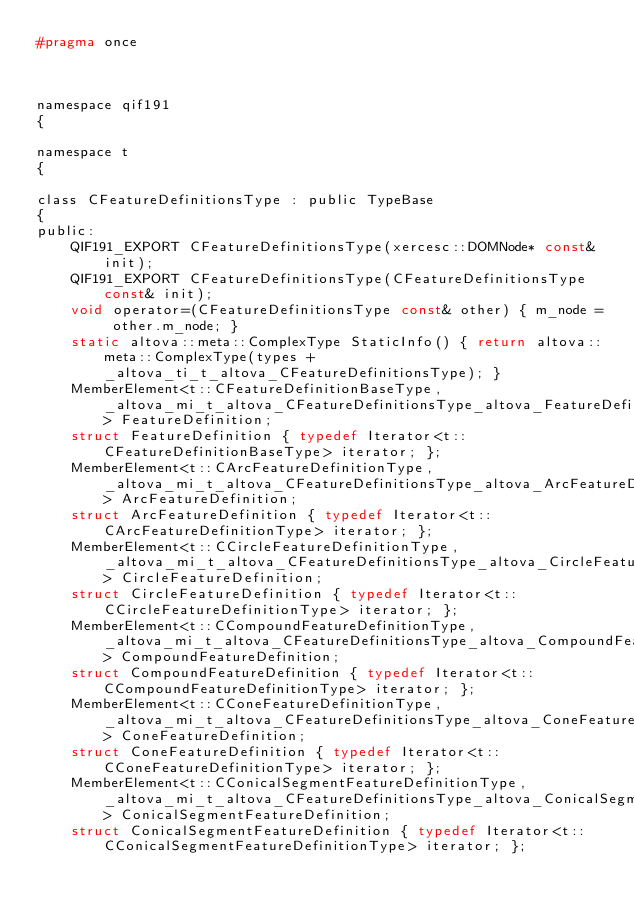<code> <loc_0><loc_0><loc_500><loc_500><_C_>#pragma once



namespace qif191
{

namespace t
{	

class CFeatureDefinitionsType : public TypeBase
{
public:
	QIF191_EXPORT CFeatureDefinitionsType(xercesc::DOMNode* const& init);
	QIF191_EXPORT CFeatureDefinitionsType(CFeatureDefinitionsType const& init);
	void operator=(CFeatureDefinitionsType const& other) { m_node = other.m_node; }
	static altova::meta::ComplexType StaticInfo() { return altova::meta::ComplexType(types + _altova_ti_t_altova_CFeatureDefinitionsType); }
	MemberElement<t::CFeatureDefinitionBaseType, _altova_mi_t_altova_CFeatureDefinitionsType_altova_FeatureDefinition> FeatureDefinition;
	struct FeatureDefinition { typedef Iterator<t::CFeatureDefinitionBaseType> iterator; };
	MemberElement<t::CArcFeatureDefinitionType, _altova_mi_t_altova_CFeatureDefinitionsType_altova_ArcFeatureDefinition> ArcFeatureDefinition;
	struct ArcFeatureDefinition { typedef Iterator<t::CArcFeatureDefinitionType> iterator; };
	MemberElement<t::CCircleFeatureDefinitionType, _altova_mi_t_altova_CFeatureDefinitionsType_altova_CircleFeatureDefinition> CircleFeatureDefinition;
	struct CircleFeatureDefinition { typedef Iterator<t::CCircleFeatureDefinitionType> iterator; };
	MemberElement<t::CCompoundFeatureDefinitionType, _altova_mi_t_altova_CFeatureDefinitionsType_altova_CompoundFeatureDefinition> CompoundFeatureDefinition;
	struct CompoundFeatureDefinition { typedef Iterator<t::CCompoundFeatureDefinitionType> iterator; };
	MemberElement<t::CConeFeatureDefinitionType, _altova_mi_t_altova_CFeatureDefinitionsType_altova_ConeFeatureDefinition> ConeFeatureDefinition;
	struct ConeFeatureDefinition { typedef Iterator<t::CConeFeatureDefinitionType> iterator; };
	MemberElement<t::CConicalSegmentFeatureDefinitionType, _altova_mi_t_altova_CFeatureDefinitionsType_altova_ConicalSegmentFeatureDefinition> ConicalSegmentFeatureDefinition;
	struct ConicalSegmentFeatureDefinition { typedef Iterator<t::CConicalSegmentFeatureDefinitionType> iterator; };</code> 